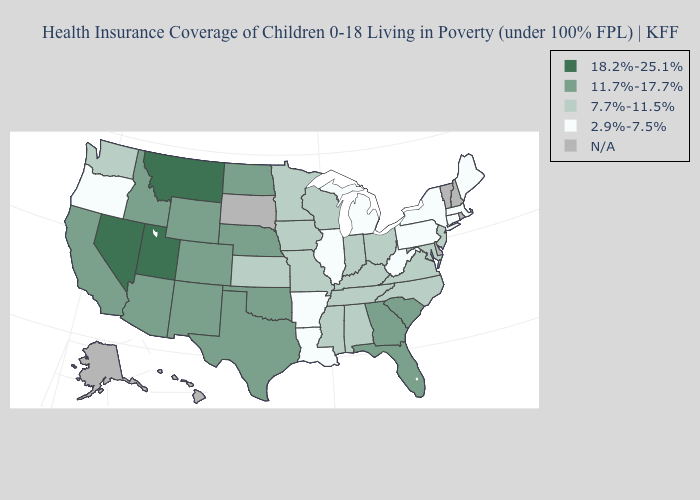How many symbols are there in the legend?
Be succinct. 5. Does the first symbol in the legend represent the smallest category?
Keep it brief. No. Among the states that border Iowa , which have the highest value?
Answer briefly. Nebraska. Name the states that have a value in the range 18.2%-25.1%?
Quick response, please. Montana, Nevada, Utah. Does Maine have the highest value in the Northeast?
Give a very brief answer. No. What is the value of Vermont?
Quick response, please. N/A. What is the highest value in states that border Wisconsin?
Concise answer only. 7.7%-11.5%. Name the states that have a value in the range 18.2%-25.1%?
Write a very short answer. Montana, Nevada, Utah. Name the states that have a value in the range 18.2%-25.1%?
Answer briefly. Montana, Nevada, Utah. Does Montana have the highest value in the USA?
Quick response, please. Yes. What is the value of Utah?
Keep it brief. 18.2%-25.1%. Does Arkansas have the lowest value in the USA?
Concise answer only. Yes. Name the states that have a value in the range 2.9%-7.5%?
Concise answer only. Arkansas, Connecticut, Illinois, Louisiana, Maine, Massachusetts, Michigan, New York, Oregon, Pennsylvania, West Virginia. What is the highest value in the Northeast ?
Answer briefly. 7.7%-11.5%. 